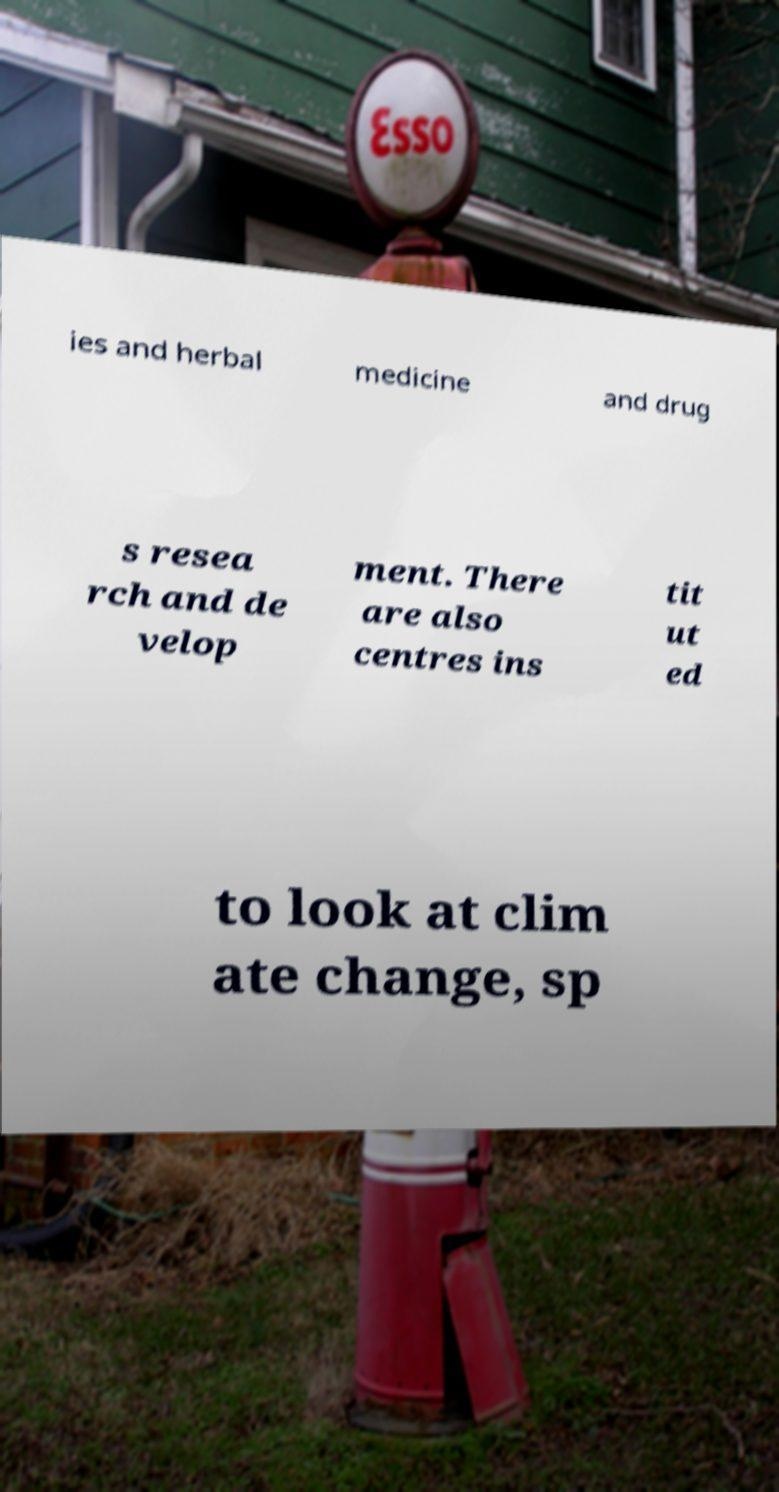What messages or text are displayed in this image? I need them in a readable, typed format. ies and herbal medicine and drug s resea rch and de velop ment. There are also centres ins tit ut ed to look at clim ate change, sp 